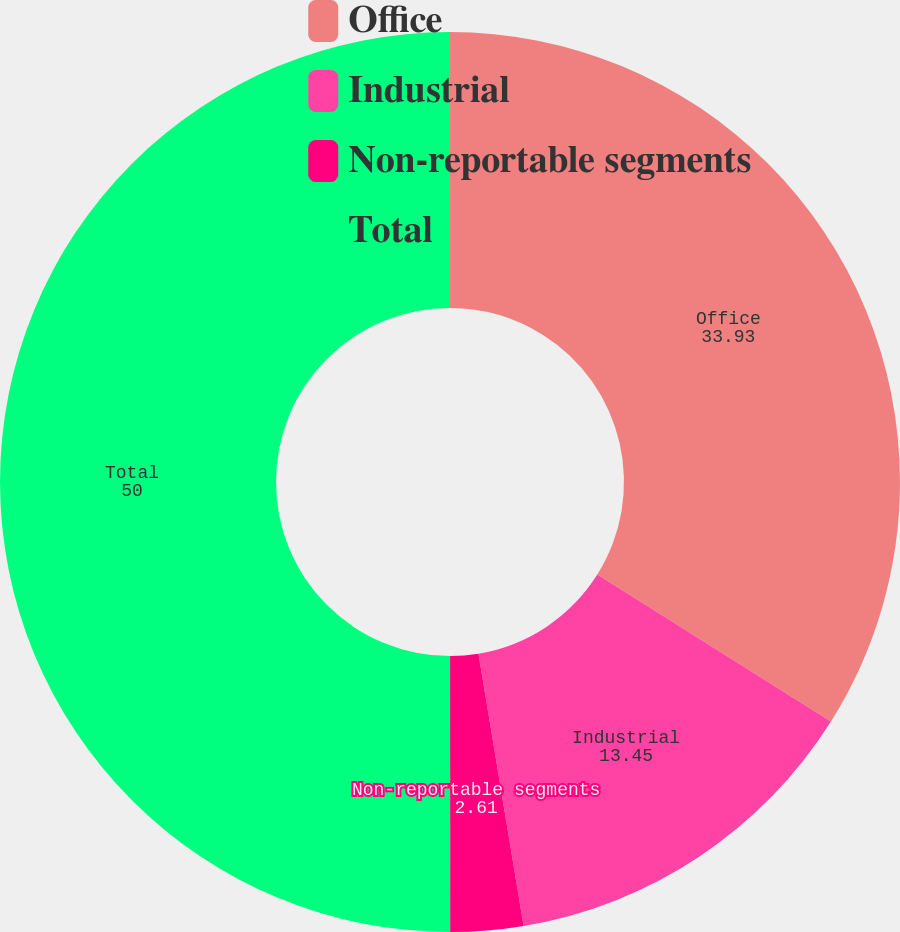<chart> <loc_0><loc_0><loc_500><loc_500><pie_chart><fcel>Office<fcel>Industrial<fcel>Non-reportable segments<fcel>Total<nl><fcel>33.93%<fcel>13.45%<fcel>2.61%<fcel>50.0%<nl></chart> 